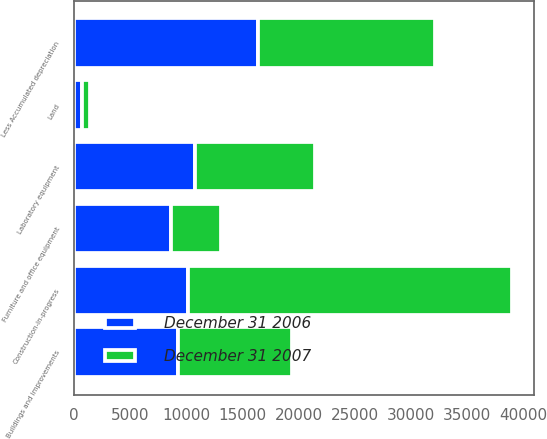<chart> <loc_0><loc_0><loc_500><loc_500><stacked_bar_chart><ecel><fcel>Land<fcel>Buildings and improvements<fcel>Laboratory equipment<fcel>Furniture and office equipment<fcel>Construction-in-progress<fcel>Less Accumulated depreciation<nl><fcel>December 31 2006<fcel>692<fcel>9266<fcel>10742<fcel>8645<fcel>10163<fcel>16370<nl><fcel>December 31 2007<fcel>692<fcel>10163<fcel>10735<fcel>4453<fcel>28827<fcel>15735<nl></chart> 